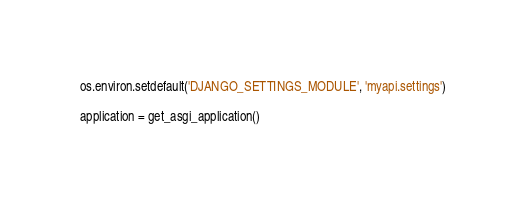Convert code to text. <code><loc_0><loc_0><loc_500><loc_500><_Python_>
os.environ.setdefault('DJANGO_SETTINGS_MODULE', 'myapi.settings')

application = get_asgi_application()
</code> 